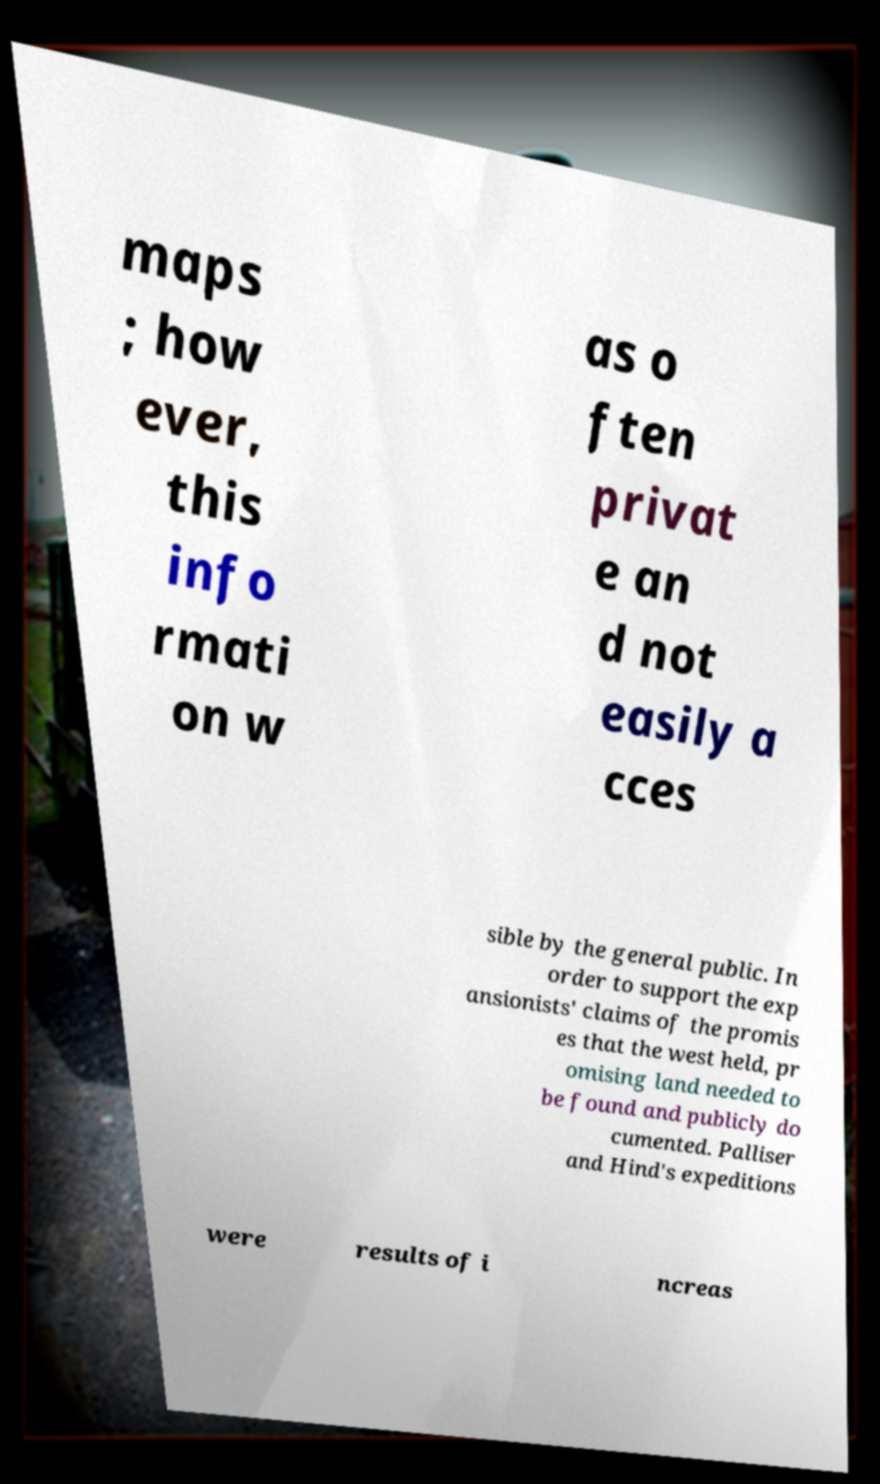I need the written content from this picture converted into text. Can you do that? maps ; how ever, this info rmati on w as o ften privat e an d not easily a cces sible by the general public. In order to support the exp ansionists' claims of the promis es that the west held, pr omising land needed to be found and publicly do cumented. Palliser and Hind's expeditions were results of i ncreas 